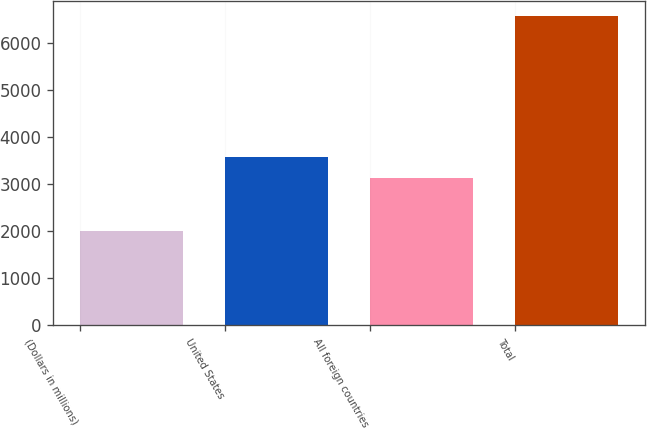Convert chart. <chart><loc_0><loc_0><loc_500><loc_500><bar_chart><fcel>(Dollars in millions)<fcel>United States<fcel>All foreign countries<fcel>Total<nl><fcel>2004<fcel>3581.6<fcel>3124<fcel>6580<nl></chart> 